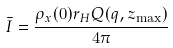Convert formula to latex. <formula><loc_0><loc_0><loc_500><loc_500>\bar { I } = \frac { \rho _ { x } ( 0 ) r _ { H } Q ( q , z _ { \max } ) } { 4 \pi }</formula> 